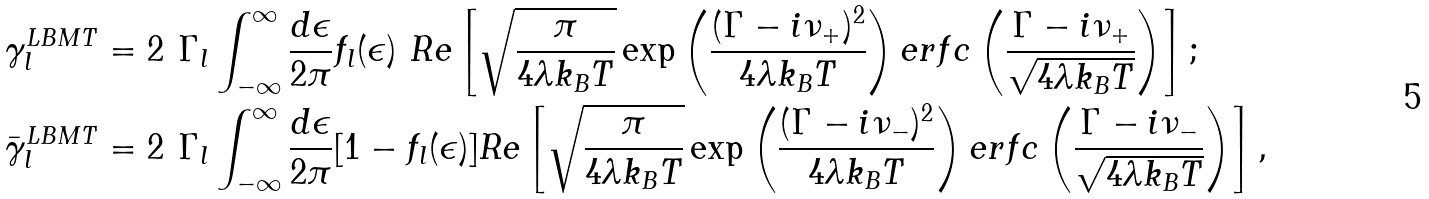<formula> <loc_0><loc_0><loc_500><loc_500>& \gamma _ { l } ^ { L B M T } = 2 \ \Gamma _ { l } \int _ { - \infty } ^ { \infty } \frac { d \epsilon } { 2 \pi } f _ { l } ( \epsilon ) \ R e \left [ \sqrt { \frac { \pi } { 4 \lambda k _ { B } T } } \exp \left ( \frac { ( \Gamma - i \nu _ { + } ) ^ { 2 } } { 4 \lambda k _ { B } T } \right ) e r f c \left ( \frac { \Gamma - i \nu _ { + } } { \sqrt { 4 \lambda k _ { B } T } } \right ) \right ] ; \\ & \bar { \gamma } _ { l } ^ { L B M T } = 2 \ \Gamma _ { l } \int _ { - \infty } ^ { \infty } \frac { d \epsilon } { 2 \pi } [ 1 - f _ { l } ( \epsilon ) ] R e \left [ \sqrt { \frac { \pi } { 4 \lambda k _ { B } T } } \exp \left ( \frac { ( \Gamma - i \nu _ { - } ) ^ { 2 } } { 4 \lambda k _ { B } T } \right ) e r f c \left ( \frac { \Gamma - i \nu _ { - } } { \sqrt { 4 \lambda k _ { B } T } } \right ) \right ] ,</formula> 